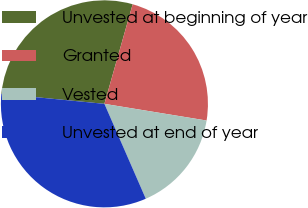Convert chart to OTSL. <chart><loc_0><loc_0><loc_500><loc_500><pie_chart><fcel>Unvested at beginning of year<fcel>Granted<fcel>Vested<fcel>Unvested at end of year<nl><fcel>27.86%<fcel>23.18%<fcel>15.88%<fcel>33.09%<nl></chart> 